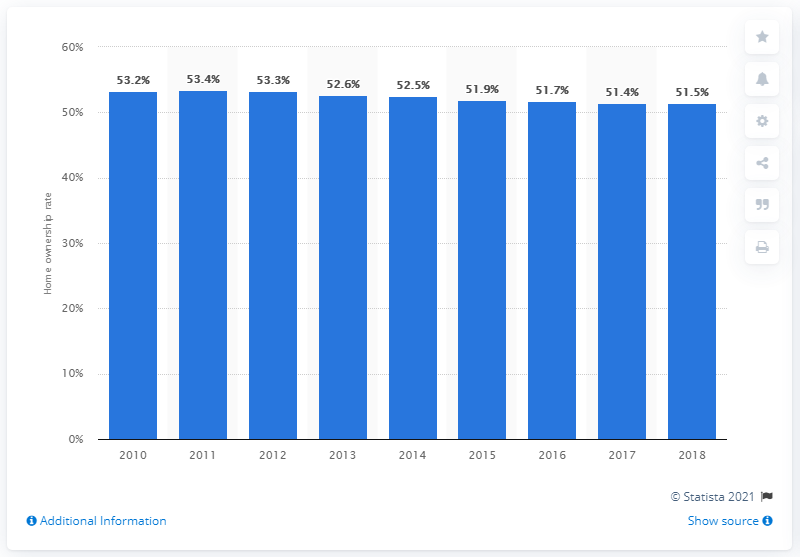Indicate a few pertinent items in this graphic. The home ownership rate in Germany was 51.5% between 2008 and 2018. 